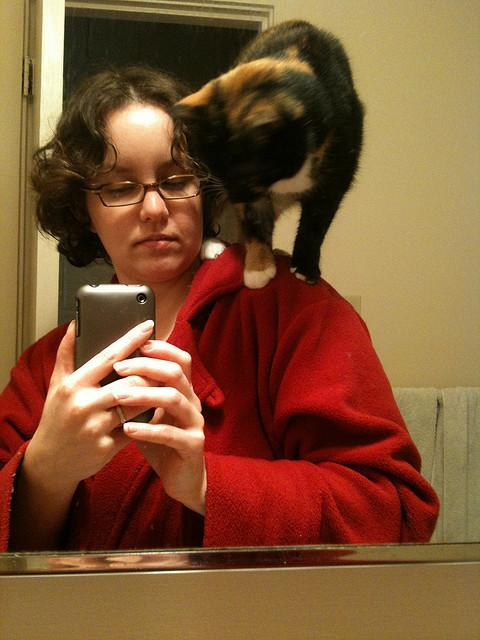What bathroom fixture is located in front of the woman at waist height? Please explain your reasoning. sink. The woman is near her bathroom mirror which is usually near the sink. 